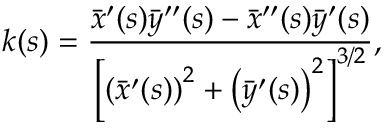<formula> <loc_0><loc_0><loc_500><loc_500>k ( s ) = \frac { \bar { x } ^ { \prime } ( s ) \bar { y } ^ { \prime \prime } ( s ) - \bar { x } ^ { \prime \prime } ( s ) \bar { y } ^ { \prime } ( s ) } { \left [ \left ( \bar { x } ^ { \prime } ( s ) \right ) ^ { 2 } + \left ( \bar { y } ^ { \prime } ( s ) \right ) ^ { 2 } \right ] ^ { 3 / 2 } } ,</formula> 